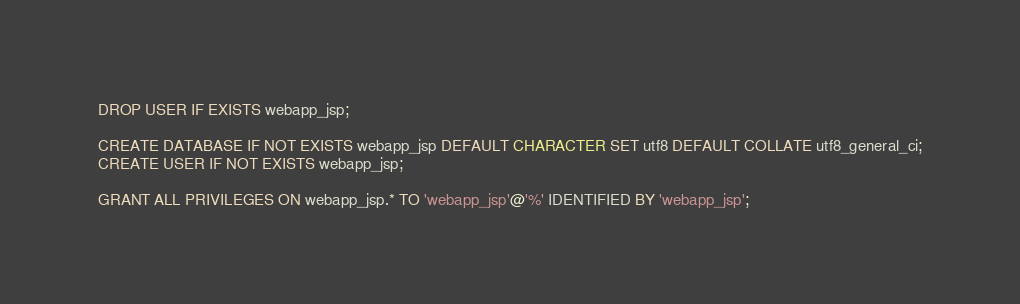<code> <loc_0><loc_0><loc_500><loc_500><_SQL_>DROP USER IF EXISTS webapp_jsp;

CREATE DATABASE IF NOT EXISTS webapp_jsp DEFAULT CHARACTER SET utf8 DEFAULT COLLATE utf8_general_ci;
CREATE USER IF NOT EXISTS webapp_jsp;

GRANT ALL PRIVILEGES ON webapp_jsp.* TO 'webapp_jsp'@'%' IDENTIFIED BY 'webapp_jsp';
</code> 